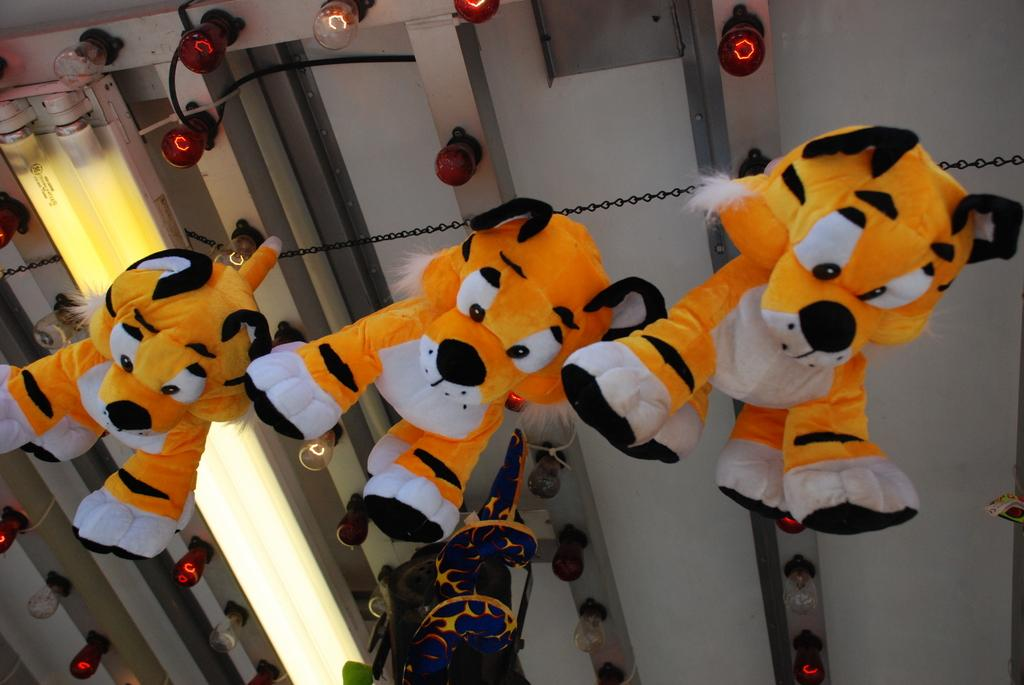What type of toys are hanging from the ceiling in the image? There are tiger toys hanging on a chain from the ceiling. What else can be seen on the ceiling in the image? There are rods with lights and tube lights on the ceiling. What type of badge can be seen on the tiger toys in the image? There are no badges present on the tiger toys in the image. How does the spoon help the tiger toys in the image? There are no spoons present in the image, so they cannot help the tiger toys. 